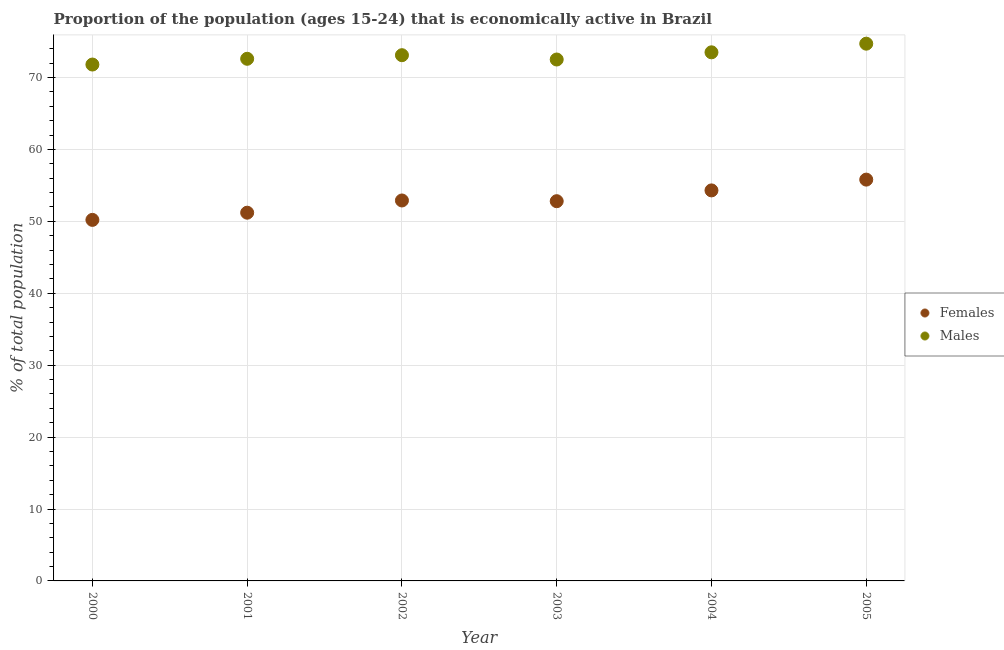What is the percentage of economically active male population in 2004?
Offer a very short reply. 73.5. Across all years, what is the maximum percentage of economically active female population?
Give a very brief answer. 55.8. Across all years, what is the minimum percentage of economically active male population?
Offer a terse response. 71.8. In which year was the percentage of economically active female population maximum?
Your answer should be very brief. 2005. In which year was the percentage of economically active female population minimum?
Make the answer very short. 2000. What is the total percentage of economically active male population in the graph?
Ensure brevity in your answer.  438.2. What is the difference between the percentage of economically active female population in 2002 and that in 2005?
Offer a terse response. -2.9. What is the difference between the percentage of economically active male population in 2003 and the percentage of economically active female population in 2002?
Your answer should be very brief. 19.6. What is the average percentage of economically active female population per year?
Provide a short and direct response. 52.87. In the year 2005, what is the difference between the percentage of economically active male population and percentage of economically active female population?
Make the answer very short. 18.9. What is the ratio of the percentage of economically active male population in 2000 to that in 2001?
Provide a short and direct response. 0.99. Is the percentage of economically active female population in 2002 less than that in 2003?
Your response must be concise. No. What is the difference between the highest and the second highest percentage of economically active male population?
Offer a terse response. 1.2. What is the difference between the highest and the lowest percentage of economically active female population?
Your response must be concise. 5.6. Is the percentage of economically active female population strictly greater than the percentage of economically active male population over the years?
Ensure brevity in your answer.  No. What is the difference between two consecutive major ticks on the Y-axis?
Offer a very short reply. 10. Does the graph contain any zero values?
Ensure brevity in your answer.  No. Does the graph contain grids?
Offer a very short reply. Yes. How many legend labels are there?
Provide a succinct answer. 2. What is the title of the graph?
Provide a short and direct response. Proportion of the population (ages 15-24) that is economically active in Brazil. What is the label or title of the Y-axis?
Your response must be concise. % of total population. What is the % of total population in Females in 2000?
Offer a terse response. 50.2. What is the % of total population in Males in 2000?
Make the answer very short. 71.8. What is the % of total population in Females in 2001?
Provide a short and direct response. 51.2. What is the % of total population of Males in 2001?
Offer a very short reply. 72.6. What is the % of total population of Females in 2002?
Provide a succinct answer. 52.9. What is the % of total population in Males in 2002?
Provide a short and direct response. 73.1. What is the % of total population in Females in 2003?
Offer a very short reply. 52.8. What is the % of total population in Males in 2003?
Offer a terse response. 72.5. What is the % of total population of Females in 2004?
Your answer should be compact. 54.3. What is the % of total population in Males in 2004?
Offer a terse response. 73.5. What is the % of total population of Females in 2005?
Your response must be concise. 55.8. What is the % of total population in Males in 2005?
Your response must be concise. 74.7. Across all years, what is the maximum % of total population in Females?
Offer a very short reply. 55.8. Across all years, what is the maximum % of total population of Males?
Make the answer very short. 74.7. Across all years, what is the minimum % of total population of Females?
Keep it short and to the point. 50.2. Across all years, what is the minimum % of total population in Males?
Provide a short and direct response. 71.8. What is the total % of total population in Females in the graph?
Ensure brevity in your answer.  317.2. What is the total % of total population of Males in the graph?
Your answer should be compact. 438.2. What is the difference between the % of total population of Females in 2000 and that in 2001?
Give a very brief answer. -1. What is the difference between the % of total population of Females in 2000 and that in 2003?
Your response must be concise. -2.6. What is the difference between the % of total population of Males in 2000 and that in 2003?
Provide a succinct answer. -0.7. What is the difference between the % of total population of Females in 2000 and that in 2004?
Offer a very short reply. -4.1. What is the difference between the % of total population of Males in 2000 and that in 2005?
Offer a very short reply. -2.9. What is the difference between the % of total population of Females in 2001 and that in 2002?
Your response must be concise. -1.7. What is the difference between the % of total population in Males in 2001 and that in 2002?
Your answer should be compact. -0.5. What is the difference between the % of total population of Males in 2002 and that in 2003?
Keep it short and to the point. 0.6. What is the difference between the % of total population in Females in 2003 and that in 2005?
Your answer should be compact. -3. What is the difference between the % of total population of Males in 2003 and that in 2005?
Make the answer very short. -2.2. What is the difference between the % of total population of Females in 2004 and that in 2005?
Keep it short and to the point. -1.5. What is the difference between the % of total population in Males in 2004 and that in 2005?
Your answer should be compact. -1.2. What is the difference between the % of total population in Females in 2000 and the % of total population in Males in 2001?
Offer a terse response. -22.4. What is the difference between the % of total population of Females in 2000 and the % of total population of Males in 2002?
Keep it short and to the point. -22.9. What is the difference between the % of total population of Females in 2000 and the % of total population of Males in 2003?
Offer a terse response. -22.3. What is the difference between the % of total population in Females in 2000 and the % of total population in Males in 2004?
Provide a succinct answer. -23.3. What is the difference between the % of total population in Females in 2000 and the % of total population in Males in 2005?
Your answer should be compact. -24.5. What is the difference between the % of total population in Females in 2001 and the % of total population in Males in 2002?
Provide a short and direct response. -21.9. What is the difference between the % of total population in Females in 2001 and the % of total population in Males in 2003?
Give a very brief answer. -21.3. What is the difference between the % of total population of Females in 2001 and the % of total population of Males in 2004?
Offer a terse response. -22.3. What is the difference between the % of total population of Females in 2001 and the % of total population of Males in 2005?
Your response must be concise. -23.5. What is the difference between the % of total population in Females in 2002 and the % of total population in Males in 2003?
Your response must be concise. -19.6. What is the difference between the % of total population in Females in 2002 and the % of total population in Males in 2004?
Your answer should be compact. -20.6. What is the difference between the % of total population of Females in 2002 and the % of total population of Males in 2005?
Offer a terse response. -21.8. What is the difference between the % of total population in Females in 2003 and the % of total population in Males in 2004?
Your answer should be compact. -20.7. What is the difference between the % of total population of Females in 2003 and the % of total population of Males in 2005?
Your response must be concise. -21.9. What is the difference between the % of total population in Females in 2004 and the % of total population in Males in 2005?
Your answer should be very brief. -20.4. What is the average % of total population in Females per year?
Provide a succinct answer. 52.87. What is the average % of total population in Males per year?
Keep it short and to the point. 73.03. In the year 2000, what is the difference between the % of total population of Females and % of total population of Males?
Offer a very short reply. -21.6. In the year 2001, what is the difference between the % of total population in Females and % of total population in Males?
Give a very brief answer. -21.4. In the year 2002, what is the difference between the % of total population of Females and % of total population of Males?
Your response must be concise. -20.2. In the year 2003, what is the difference between the % of total population of Females and % of total population of Males?
Make the answer very short. -19.7. In the year 2004, what is the difference between the % of total population of Females and % of total population of Males?
Make the answer very short. -19.2. In the year 2005, what is the difference between the % of total population in Females and % of total population in Males?
Keep it short and to the point. -18.9. What is the ratio of the % of total population in Females in 2000 to that in 2001?
Provide a short and direct response. 0.98. What is the ratio of the % of total population in Males in 2000 to that in 2001?
Make the answer very short. 0.99. What is the ratio of the % of total population in Females in 2000 to that in 2002?
Offer a terse response. 0.95. What is the ratio of the % of total population in Males in 2000 to that in 2002?
Ensure brevity in your answer.  0.98. What is the ratio of the % of total population of Females in 2000 to that in 2003?
Provide a succinct answer. 0.95. What is the ratio of the % of total population of Males in 2000 to that in 2003?
Provide a succinct answer. 0.99. What is the ratio of the % of total population in Females in 2000 to that in 2004?
Your answer should be very brief. 0.92. What is the ratio of the % of total population in Males in 2000 to that in 2004?
Offer a very short reply. 0.98. What is the ratio of the % of total population of Females in 2000 to that in 2005?
Ensure brevity in your answer.  0.9. What is the ratio of the % of total population of Males in 2000 to that in 2005?
Give a very brief answer. 0.96. What is the ratio of the % of total population in Females in 2001 to that in 2002?
Provide a short and direct response. 0.97. What is the ratio of the % of total population of Males in 2001 to that in 2002?
Your answer should be compact. 0.99. What is the ratio of the % of total population of Females in 2001 to that in 2003?
Offer a very short reply. 0.97. What is the ratio of the % of total population in Females in 2001 to that in 2004?
Make the answer very short. 0.94. What is the ratio of the % of total population of Females in 2001 to that in 2005?
Offer a terse response. 0.92. What is the ratio of the % of total population in Males in 2001 to that in 2005?
Ensure brevity in your answer.  0.97. What is the ratio of the % of total population of Females in 2002 to that in 2003?
Provide a succinct answer. 1. What is the ratio of the % of total population in Males in 2002 to that in 2003?
Provide a short and direct response. 1.01. What is the ratio of the % of total population of Females in 2002 to that in 2004?
Make the answer very short. 0.97. What is the ratio of the % of total population in Males in 2002 to that in 2004?
Your answer should be compact. 0.99. What is the ratio of the % of total population in Females in 2002 to that in 2005?
Your answer should be compact. 0.95. What is the ratio of the % of total population of Males in 2002 to that in 2005?
Provide a succinct answer. 0.98. What is the ratio of the % of total population of Females in 2003 to that in 2004?
Provide a short and direct response. 0.97. What is the ratio of the % of total population in Males in 2003 to that in 2004?
Give a very brief answer. 0.99. What is the ratio of the % of total population of Females in 2003 to that in 2005?
Offer a very short reply. 0.95. What is the ratio of the % of total population of Males in 2003 to that in 2005?
Ensure brevity in your answer.  0.97. What is the ratio of the % of total population in Females in 2004 to that in 2005?
Your answer should be very brief. 0.97. What is the ratio of the % of total population of Males in 2004 to that in 2005?
Your answer should be compact. 0.98. What is the difference between the highest and the second highest % of total population in Females?
Make the answer very short. 1.5. What is the difference between the highest and the lowest % of total population in Females?
Offer a terse response. 5.6. 